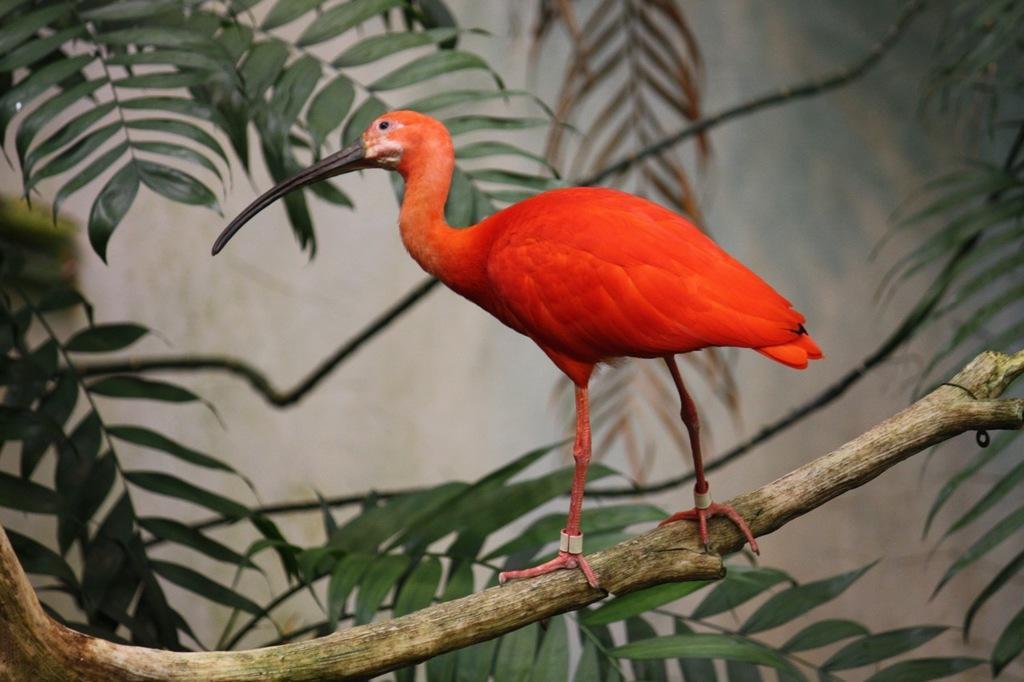In one or two sentences, can you explain what this image depicts? In this picture there is a red color bird which is standing on the tree branch. At the bottom we can see the leaves. On the right there is a plant near to the wall. 